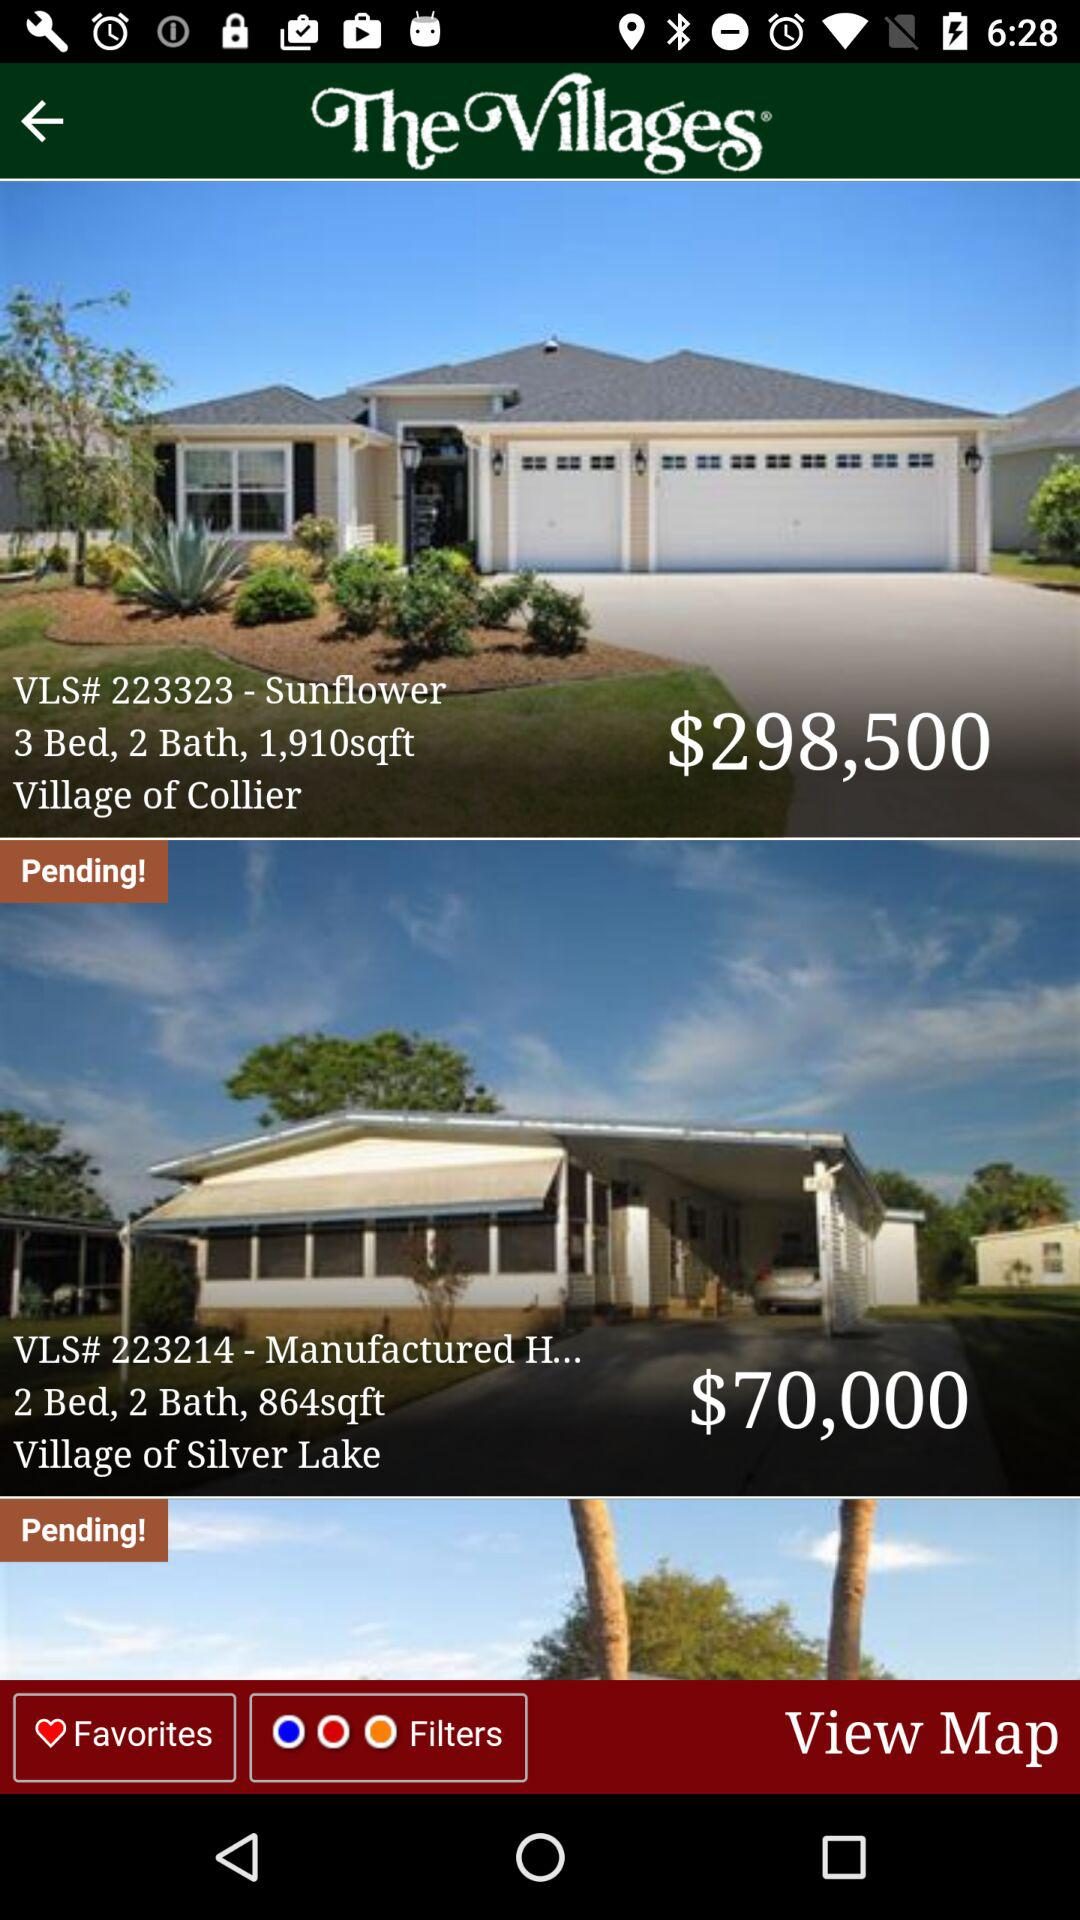How many homes are pending?
Answer the question using a single word or phrase. 2 